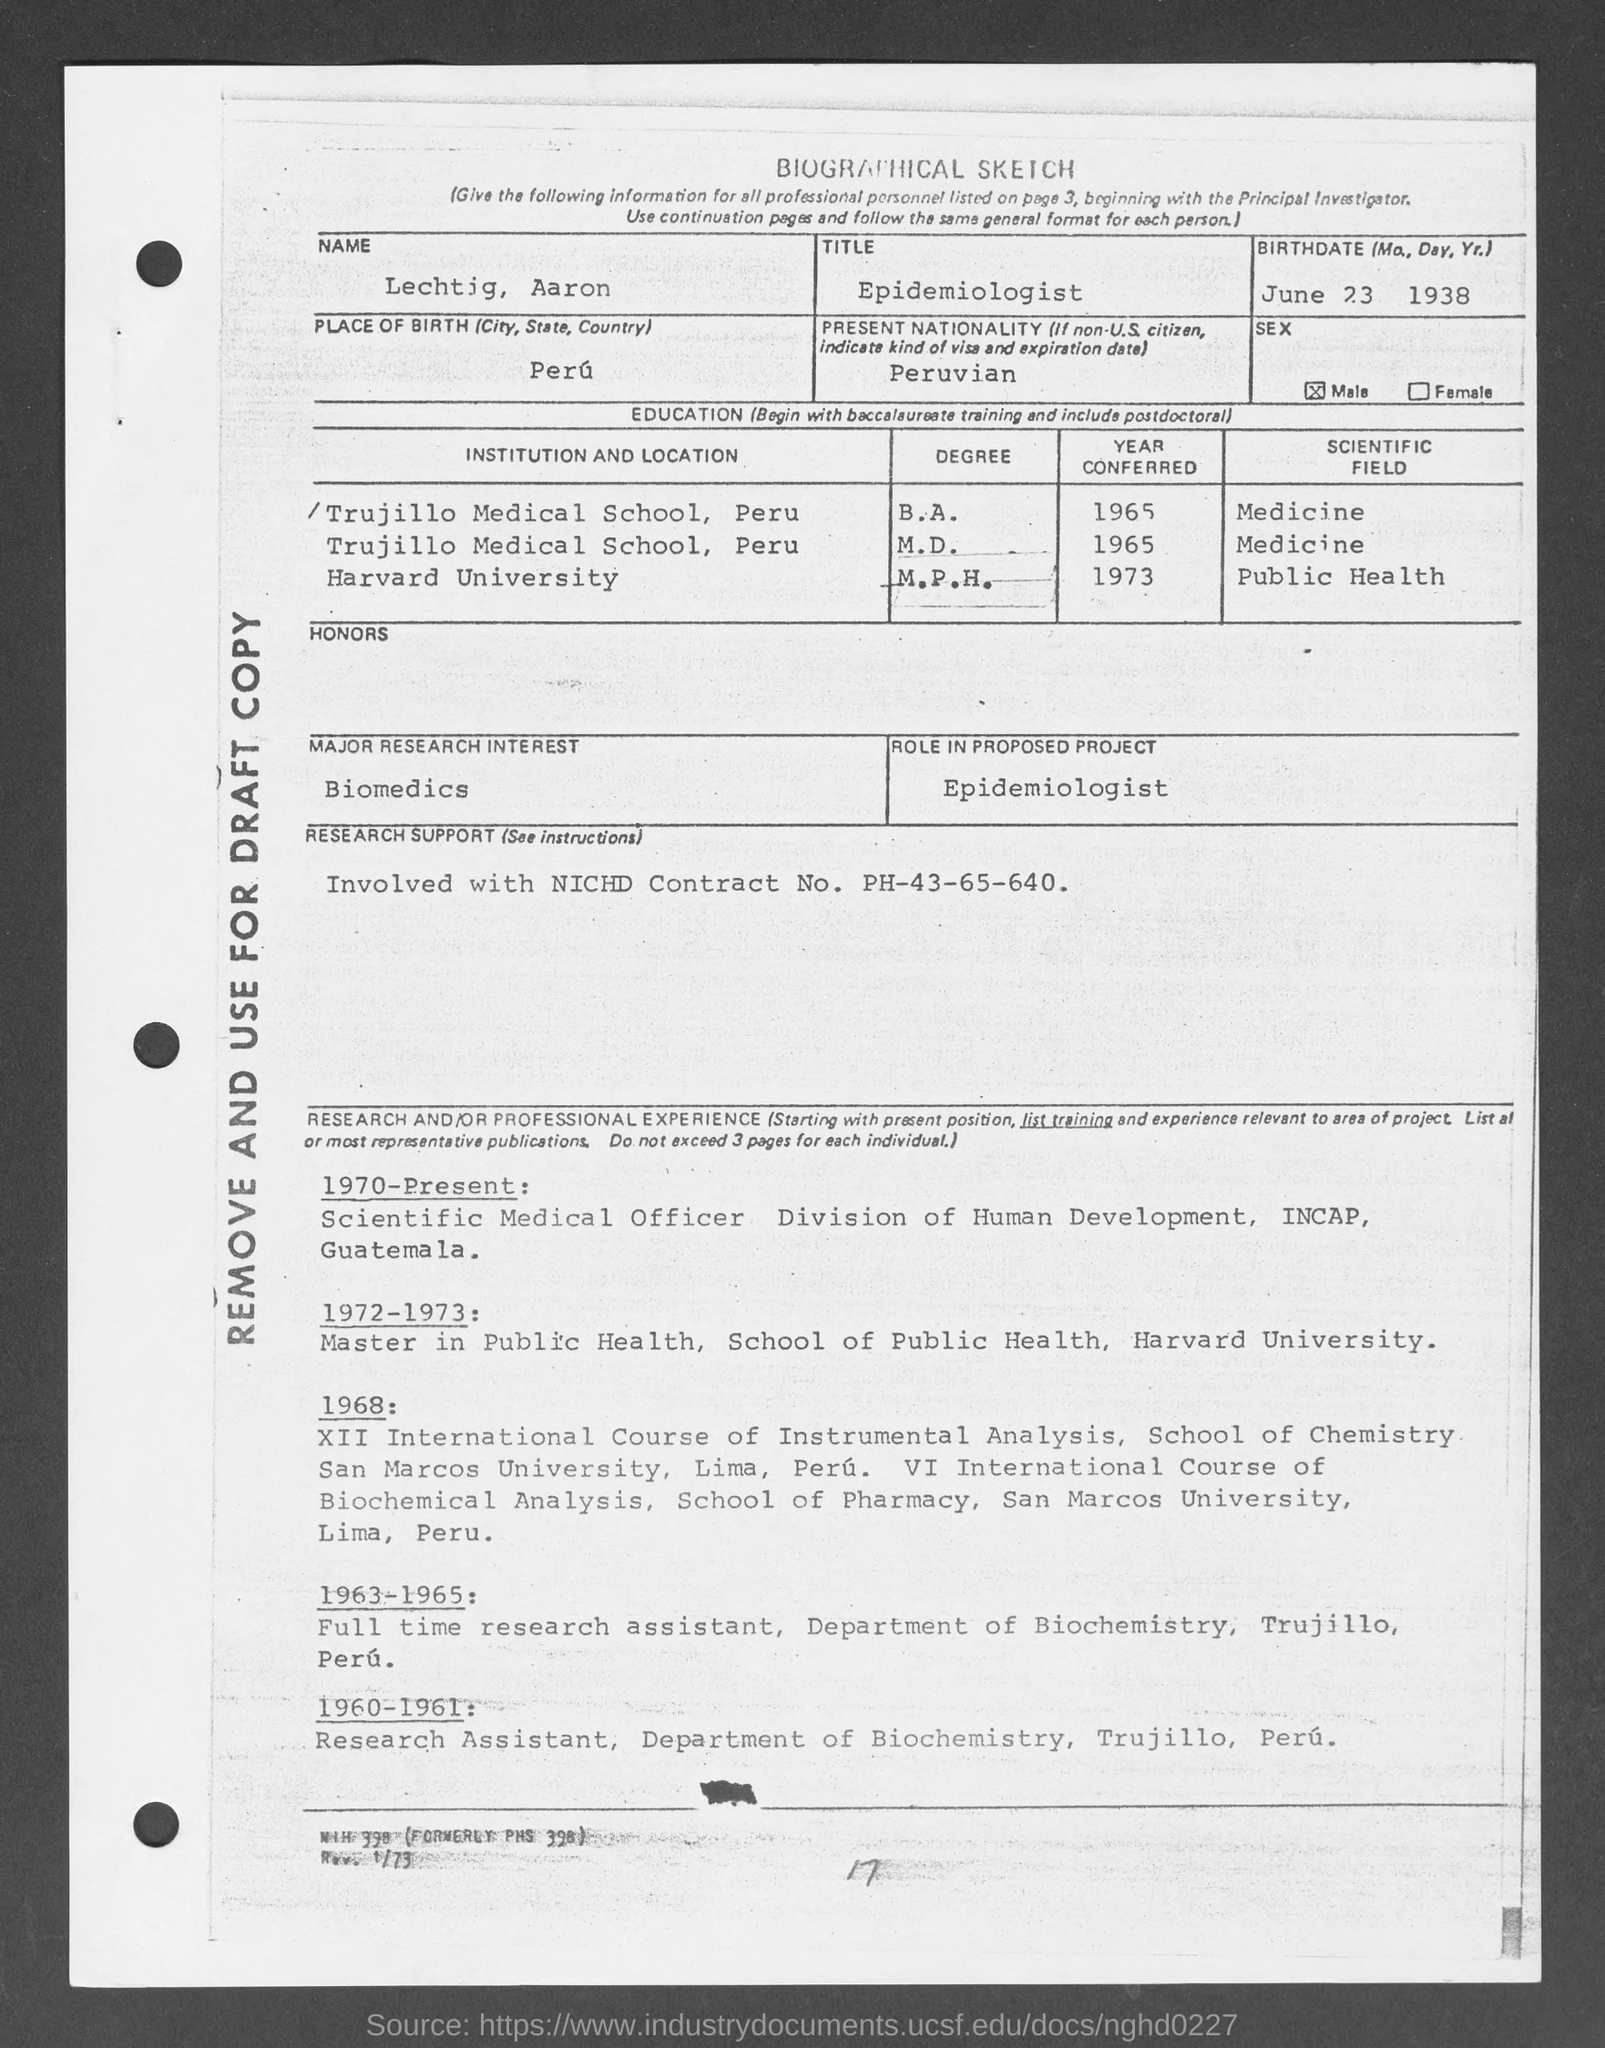What is the name mentioned in the given biological sketch ?
Offer a terse response. Lechtig, Aaron. What is the title mentioned in the given sketch ?
Your answer should be compact. Epidemiologist. Where is the place of birth as mentioned in the given sketch ?
Make the answer very short. PERU. What is the present nationality as mentioned in the given sketch ?
Provide a short and direct response. Peruvian. What is the sex mentioned in the given sketch ?
Offer a terse response. Male. What is the major research interest mentioned in the given sketch ?
Give a very brief answer. Biomedics. What is the role in proposed project as mentioned in the given sketch ?
Your response must be concise. Epidemiologist. In which scientific field he completed his b.a. in the year 1965 ?
Give a very brief answer. MEDICINE. 